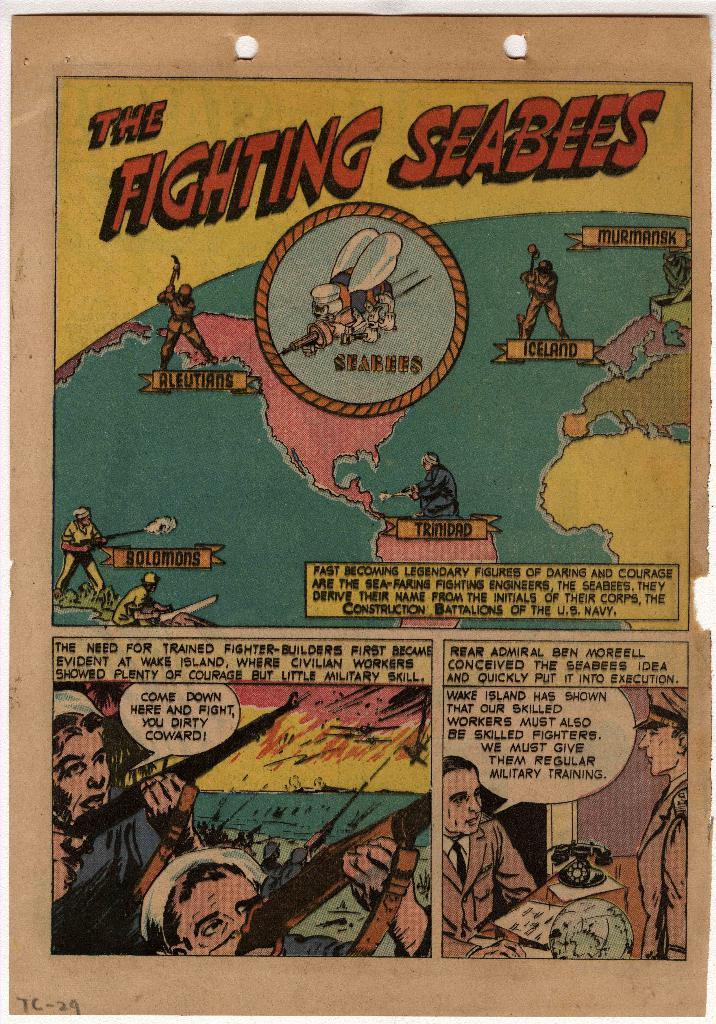What is the title of this comic?
Make the answer very short. The fighting seabees. 